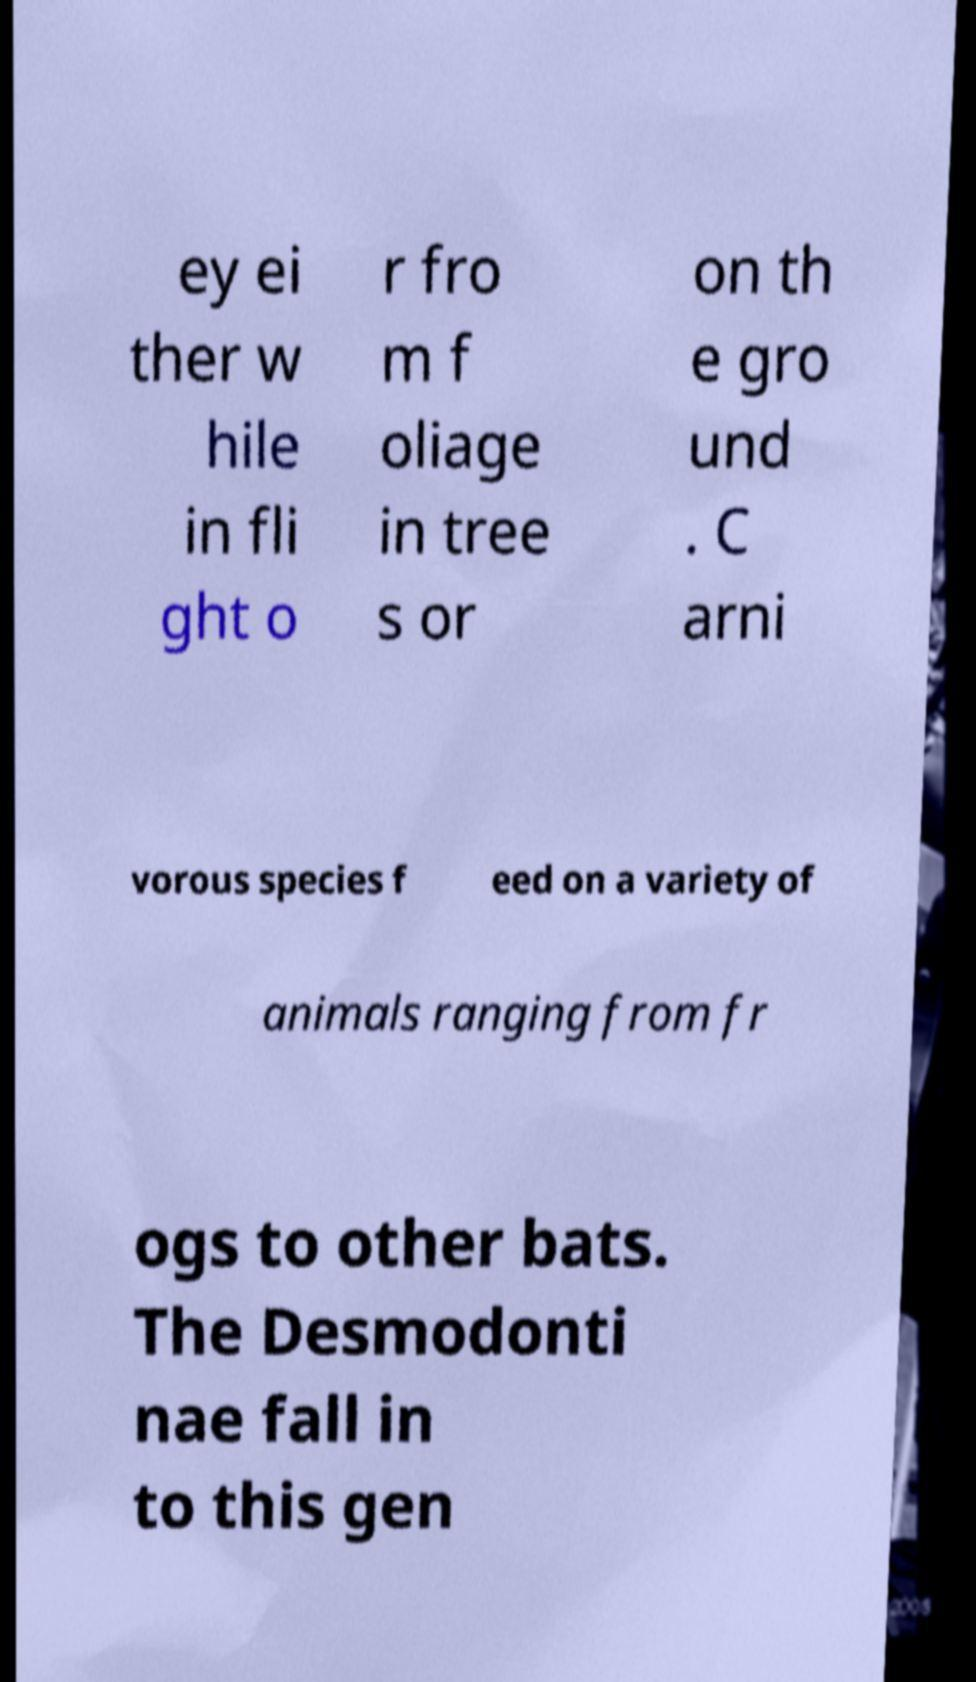Could you assist in decoding the text presented in this image and type it out clearly? ey ei ther w hile in fli ght o r fro m f oliage in tree s or on th e gro und . C arni vorous species f eed on a variety of animals ranging from fr ogs to other bats. The Desmodonti nae fall in to this gen 